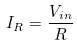Convert formula to latex. <formula><loc_0><loc_0><loc_500><loc_500>I _ { R } = \frac { V _ { i n } } { R }</formula> 